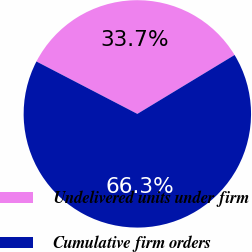Convert chart. <chart><loc_0><loc_0><loc_500><loc_500><pie_chart><fcel>Undelivered units under firm<fcel>Cumulative firm orders<nl><fcel>33.71%<fcel>66.29%<nl></chart> 